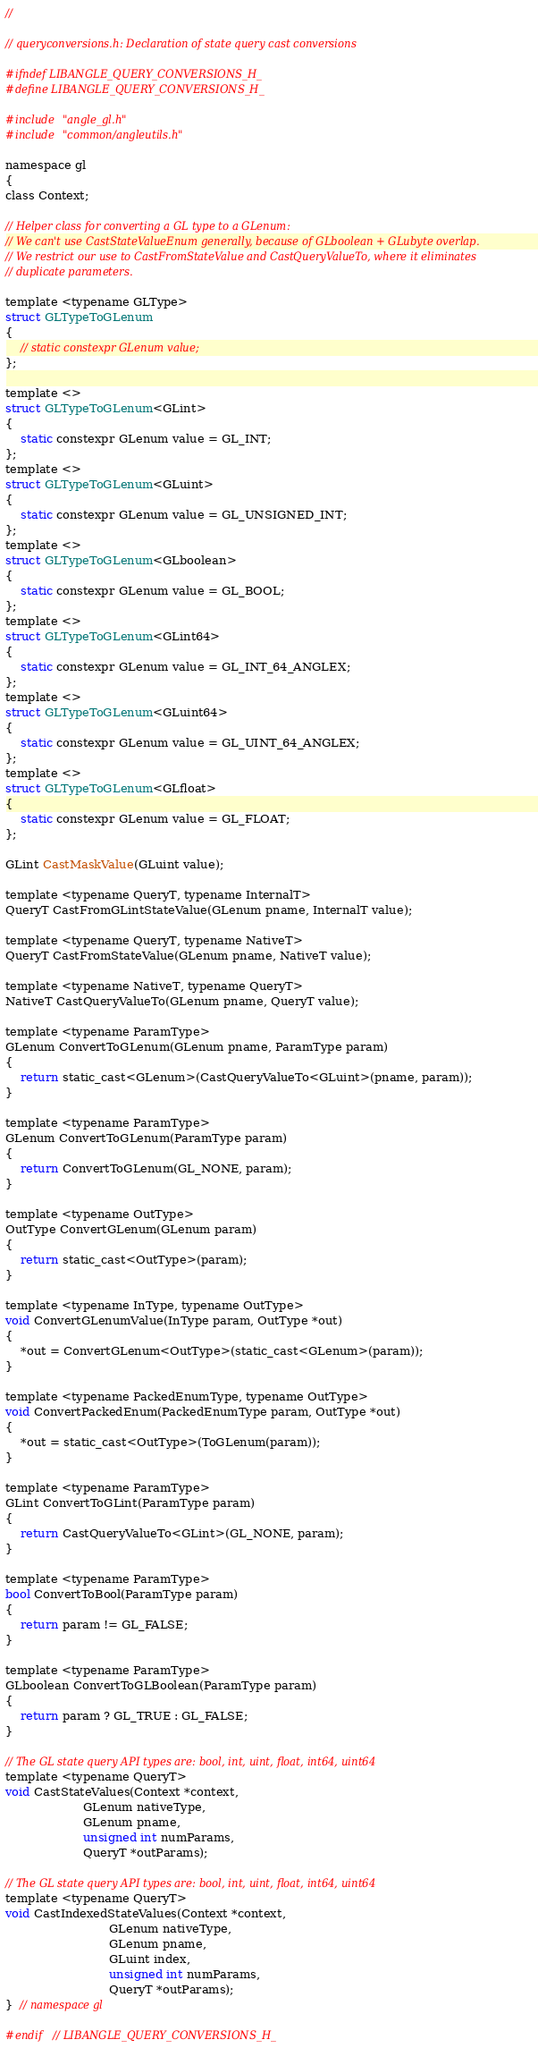<code> <loc_0><loc_0><loc_500><loc_500><_C_>//

// queryconversions.h: Declaration of state query cast conversions

#ifndef LIBANGLE_QUERY_CONVERSIONS_H_
#define LIBANGLE_QUERY_CONVERSIONS_H_

#include "angle_gl.h"
#include "common/angleutils.h"

namespace gl
{
class Context;

// Helper class for converting a GL type to a GLenum:
// We can't use CastStateValueEnum generally, because of GLboolean + GLubyte overlap.
// We restrict our use to CastFromStateValue and CastQueryValueTo, where it eliminates
// duplicate parameters.

template <typename GLType>
struct GLTypeToGLenum
{
    // static constexpr GLenum value;
};

template <>
struct GLTypeToGLenum<GLint>
{
    static constexpr GLenum value = GL_INT;
};
template <>
struct GLTypeToGLenum<GLuint>
{
    static constexpr GLenum value = GL_UNSIGNED_INT;
};
template <>
struct GLTypeToGLenum<GLboolean>
{
    static constexpr GLenum value = GL_BOOL;
};
template <>
struct GLTypeToGLenum<GLint64>
{
    static constexpr GLenum value = GL_INT_64_ANGLEX;
};
template <>
struct GLTypeToGLenum<GLuint64>
{
    static constexpr GLenum value = GL_UINT_64_ANGLEX;
};
template <>
struct GLTypeToGLenum<GLfloat>
{
    static constexpr GLenum value = GL_FLOAT;
};

GLint CastMaskValue(GLuint value);

template <typename QueryT, typename InternalT>
QueryT CastFromGLintStateValue(GLenum pname, InternalT value);

template <typename QueryT, typename NativeT>
QueryT CastFromStateValue(GLenum pname, NativeT value);

template <typename NativeT, typename QueryT>
NativeT CastQueryValueTo(GLenum pname, QueryT value);

template <typename ParamType>
GLenum ConvertToGLenum(GLenum pname, ParamType param)
{
    return static_cast<GLenum>(CastQueryValueTo<GLuint>(pname, param));
}

template <typename ParamType>
GLenum ConvertToGLenum(ParamType param)
{
    return ConvertToGLenum(GL_NONE, param);
}

template <typename OutType>
OutType ConvertGLenum(GLenum param)
{
    return static_cast<OutType>(param);
}

template <typename InType, typename OutType>
void ConvertGLenumValue(InType param, OutType *out)
{
    *out = ConvertGLenum<OutType>(static_cast<GLenum>(param));
}

template <typename PackedEnumType, typename OutType>
void ConvertPackedEnum(PackedEnumType param, OutType *out)
{
    *out = static_cast<OutType>(ToGLenum(param));
}

template <typename ParamType>
GLint ConvertToGLint(ParamType param)
{
    return CastQueryValueTo<GLint>(GL_NONE, param);
}

template <typename ParamType>
bool ConvertToBool(ParamType param)
{
    return param != GL_FALSE;
}

template <typename ParamType>
GLboolean ConvertToGLBoolean(ParamType param)
{
    return param ? GL_TRUE : GL_FALSE;
}

// The GL state query API types are: bool, int, uint, float, int64, uint64
template <typename QueryT>
void CastStateValues(Context *context,
                     GLenum nativeType,
                     GLenum pname,
                     unsigned int numParams,
                     QueryT *outParams);

// The GL state query API types are: bool, int, uint, float, int64, uint64
template <typename QueryT>
void CastIndexedStateValues(Context *context,
                            GLenum nativeType,
                            GLenum pname,
                            GLuint index,
                            unsigned int numParams,
                            QueryT *outParams);
}  // namespace gl

#endif  // LIBANGLE_QUERY_CONVERSIONS_H_
</code> 